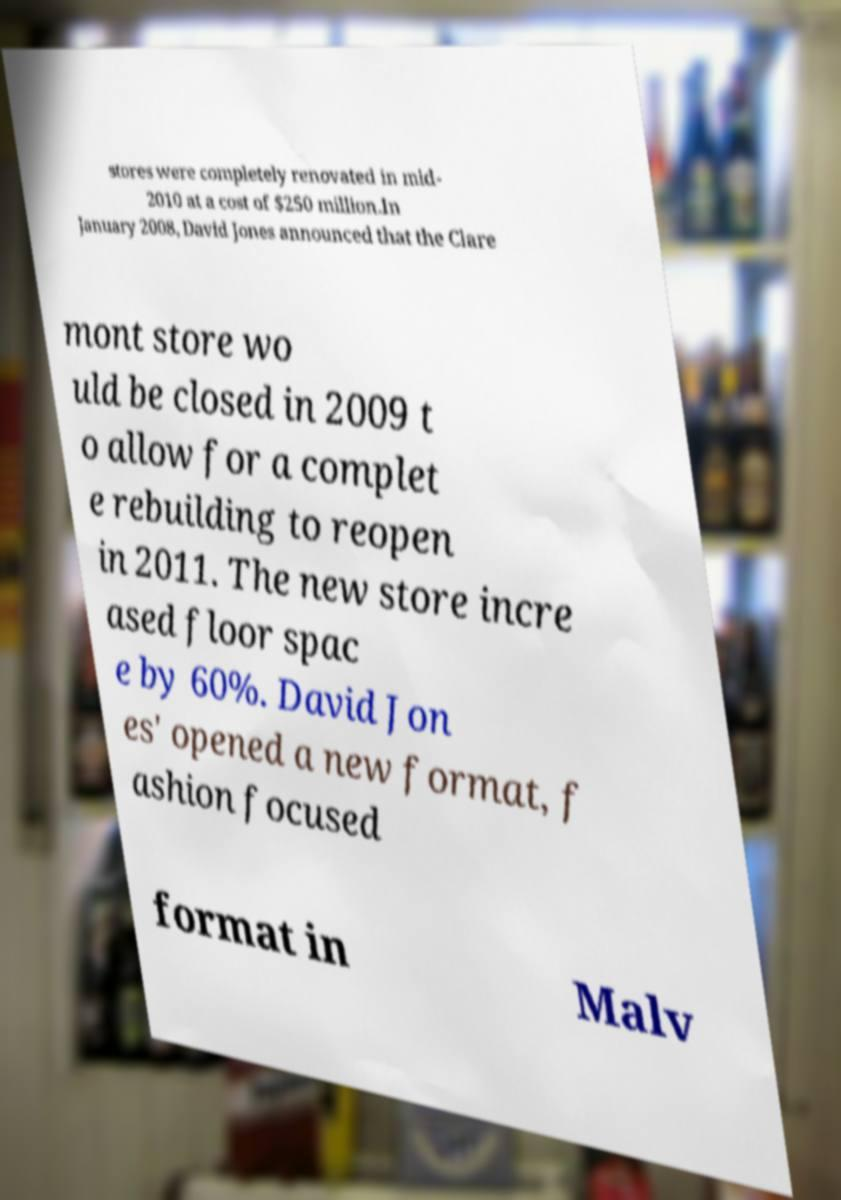For documentation purposes, I need the text within this image transcribed. Could you provide that? stores were completely renovated in mid- 2010 at a cost of $250 million.In January 2008, David Jones announced that the Clare mont store wo uld be closed in 2009 t o allow for a complet e rebuilding to reopen in 2011. The new store incre ased floor spac e by 60%. David Jon es' opened a new format, f ashion focused format in Malv 